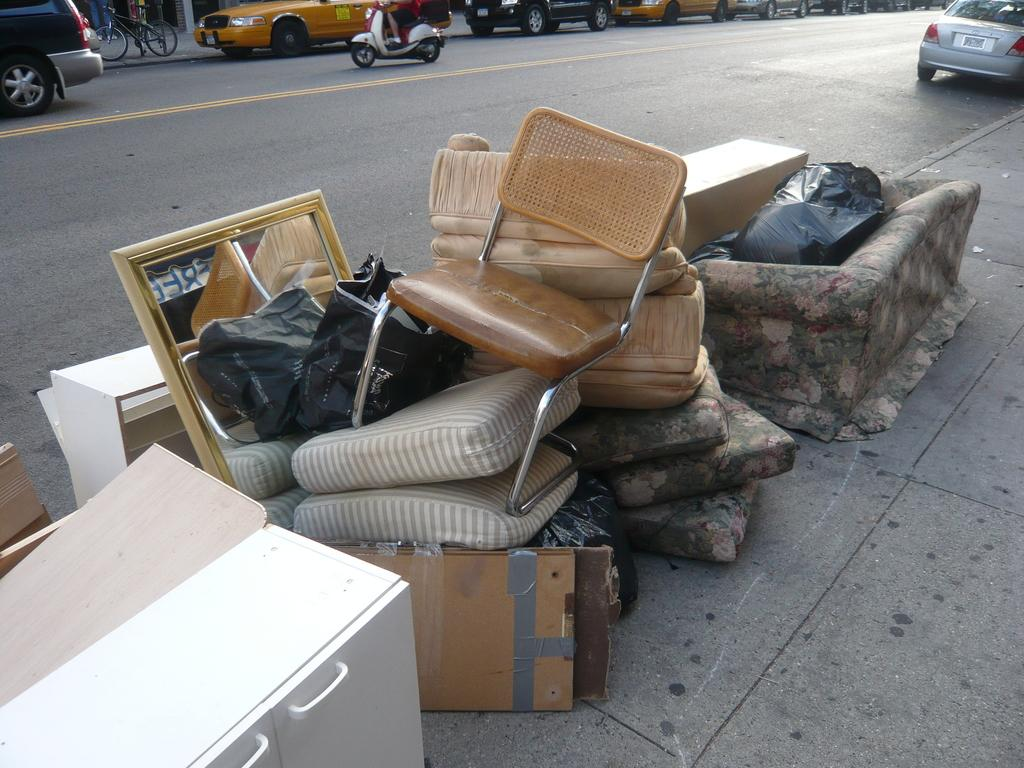What type of furniture is placed on the road in the image? There is a chair, a mirror, a bag, cushions, a white cupboard, a black cover, and a sofa placed on the road in the image. What can be seen on the road besides the furniture? Vehicles are visible on the road behind the mentioned items. Can you describe the color of the white cupboard on the road? The white cupboard on the road is white. What is the color of the black cover on the road? The black cover on the road is black. How many cats are sitting on the sofa in the image? There are no cats present in the image; it features a sofa and other items on the road. Is there any snow visible in the image? There is no snow present in the image; it is a scene on a road with various items and vehicles. 